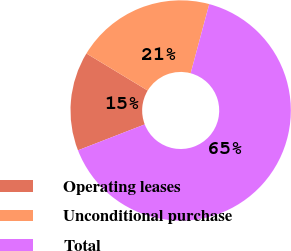Convert chart to OTSL. <chart><loc_0><loc_0><loc_500><loc_500><pie_chart><fcel>Operating leases<fcel>Unconditional purchase<fcel>Total<nl><fcel>14.55%<fcel>20.52%<fcel>64.94%<nl></chart> 